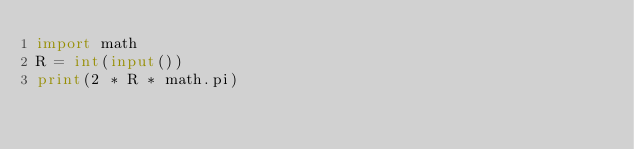<code> <loc_0><loc_0><loc_500><loc_500><_Python_>import math
R = int(input())
print(2 * R * math.pi)</code> 